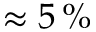<formula> <loc_0><loc_0><loc_500><loc_500>\approx 5 \, \%</formula> 